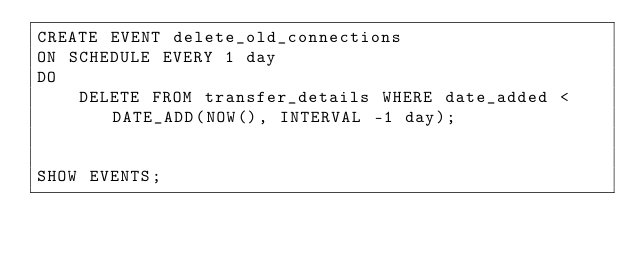Convert code to text. <code><loc_0><loc_0><loc_500><loc_500><_SQL_>CREATE EVENT delete_old_connections
ON SCHEDULE EVERY 1 day
DO
    DELETE FROM transfer_details WHERE date_added < DATE_ADD(NOW(), INTERVAL -1 day);


SHOW EVENTS;</code> 